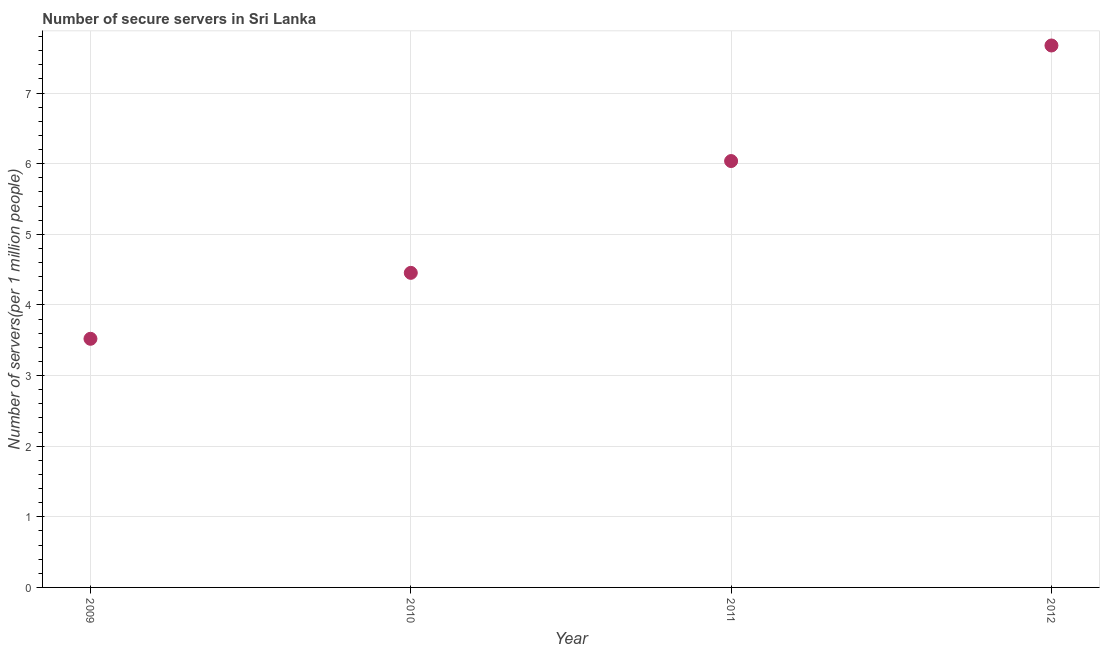What is the number of secure internet servers in 2011?
Offer a very short reply. 6.04. Across all years, what is the maximum number of secure internet servers?
Provide a short and direct response. 7.67. Across all years, what is the minimum number of secure internet servers?
Make the answer very short. 3.52. In which year was the number of secure internet servers maximum?
Ensure brevity in your answer.  2012. What is the sum of the number of secure internet servers?
Give a very brief answer. 21.69. What is the difference between the number of secure internet servers in 2009 and 2010?
Keep it short and to the point. -0.93. What is the average number of secure internet servers per year?
Offer a terse response. 5.42. What is the median number of secure internet servers?
Your answer should be compact. 5.25. In how many years, is the number of secure internet servers greater than 5.8 ?
Your answer should be compact. 2. Do a majority of the years between 2009 and 2011 (inclusive) have number of secure internet servers greater than 6.2 ?
Give a very brief answer. No. What is the ratio of the number of secure internet servers in 2011 to that in 2012?
Ensure brevity in your answer.  0.79. Is the difference between the number of secure internet servers in 2009 and 2011 greater than the difference between any two years?
Offer a very short reply. No. What is the difference between the highest and the second highest number of secure internet servers?
Ensure brevity in your answer.  1.64. What is the difference between the highest and the lowest number of secure internet servers?
Keep it short and to the point. 4.15. How many years are there in the graph?
Your answer should be compact. 4. What is the difference between two consecutive major ticks on the Y-axis?
Provide a short and direct response. 1. Are the values on the major ticks of Y-axis written in scientific E-notation?
Your answer should be very brief. No. Does the graph contain grids?
Your response must be concise. Yes. What is the title of the graph?
Ensure brevity in your answer.  Number of secure servers in Sri Lanka. What is the label or title of the X-axis?
Provide a succinct answer. Year. What is the label or title of the Y-axis?
Offer a very short reply. Number of servers(per 1 million people). What is the Number of servers(per 1 million people) in 2009?
Provide a succinct answer. 3.52. What is the Number of servers(per 1 million people) in 2010?
Your answer should be very brief. 4.45. What is the Number of servers(per 1 million people) in 2011?
Provide a short and direct response. 6.04. What is the Number of servers(per 1 million people) in 2012?
Your answer should be very brief. 7.67. What is the difference between the Number of servers(per 1 million people) in 2009 and 2010?
Provide a succinct answer. -0.93. What is the difference between the Number of servers(per 1 million people) in 2009 and 2011?
Offer a terse response. -2.52. What is the difference between the Number of servers(per 1 million people) in 2009 and 2012?
Your answer should be compact. -4.15. What is the difference between the Number of servers(per 1 million people) in 2010 and 2011?
Your answer should be compact. -1.58. What is the difference between the Number of servers(per 1 million people) in 2010 and 2012?
Your answer should be very brief. -3.22. What is the difference between the Number of servers(per 1 million people) in 2011 and 2012?
Give a very brief answer. -1.64. What is the ratio of the Number of servers(per 1 million people) in 2009 to that in 2010?
Give a very brief answer. 0.79. What is the ratio of the Number of servers(per 1 million people) in 2009 to that in 2011?
Your response must be concise. 0.58. What is the ratio of the Number of servers(per 1 million people) in 2009 to that in 2012?
Ensure brevity in your answer.  0.46. What is the ratio of the Number of servers(per 1 million people) in 2010 to that in 2011?
Keep it short and to the point. 0.74. What is the ratio of the Number of servers(per 1 million people) in 2010 to that in 2012?
Your answer should be compact. 0.58. What is the ratio of the Number of servers(per 1 million people) in 2011 to that in 2012?
Keep it short and to the point. 0.79. 